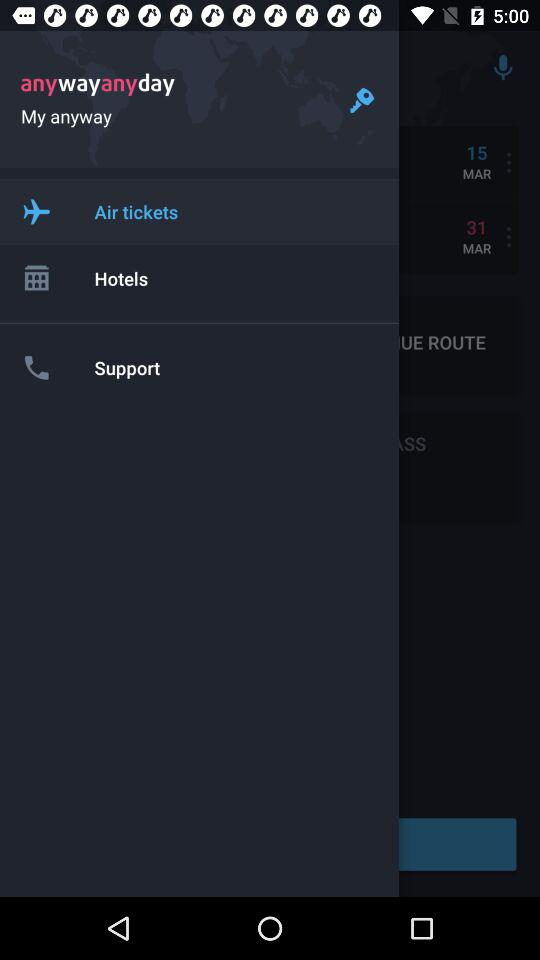What is the application name? The application name is "anywayanyday". 